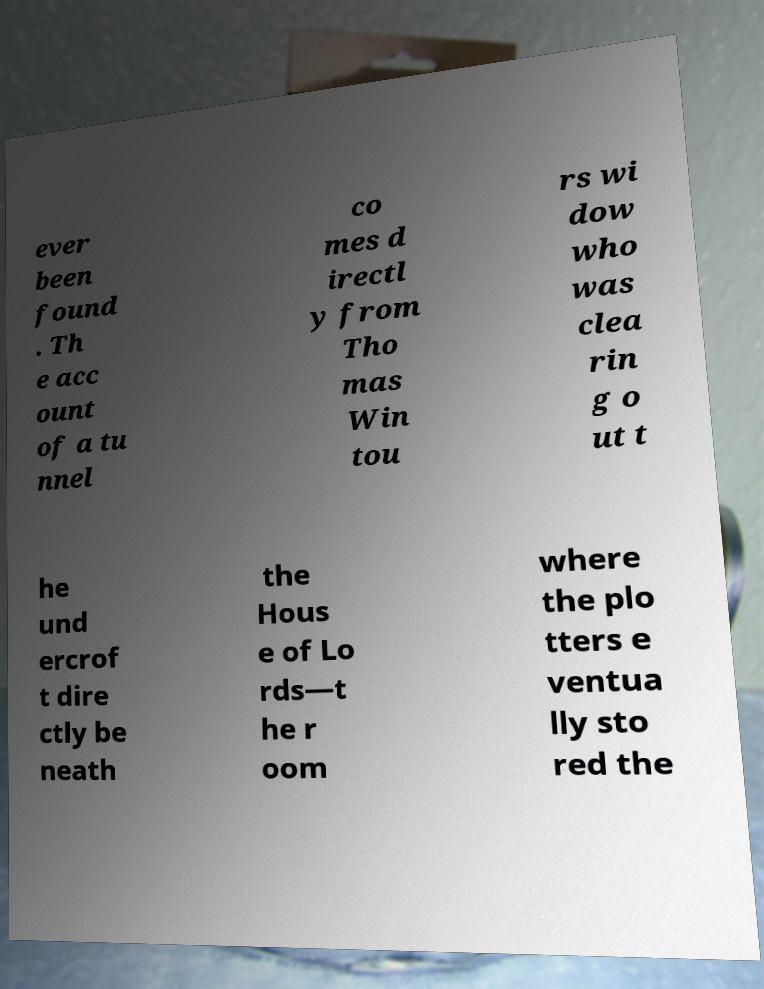I need the written content from this picture converted into text. Can you do that? ever been found . Th e acc ount of a tu nnel co mes d irectl y from Tho mas Win tou rs wi dow who was clea rin g o ut t he und ercrof t dire ctly be neath the Hous e of Lo rds—t he r oom where the plo tters e ventua lly sto red the 